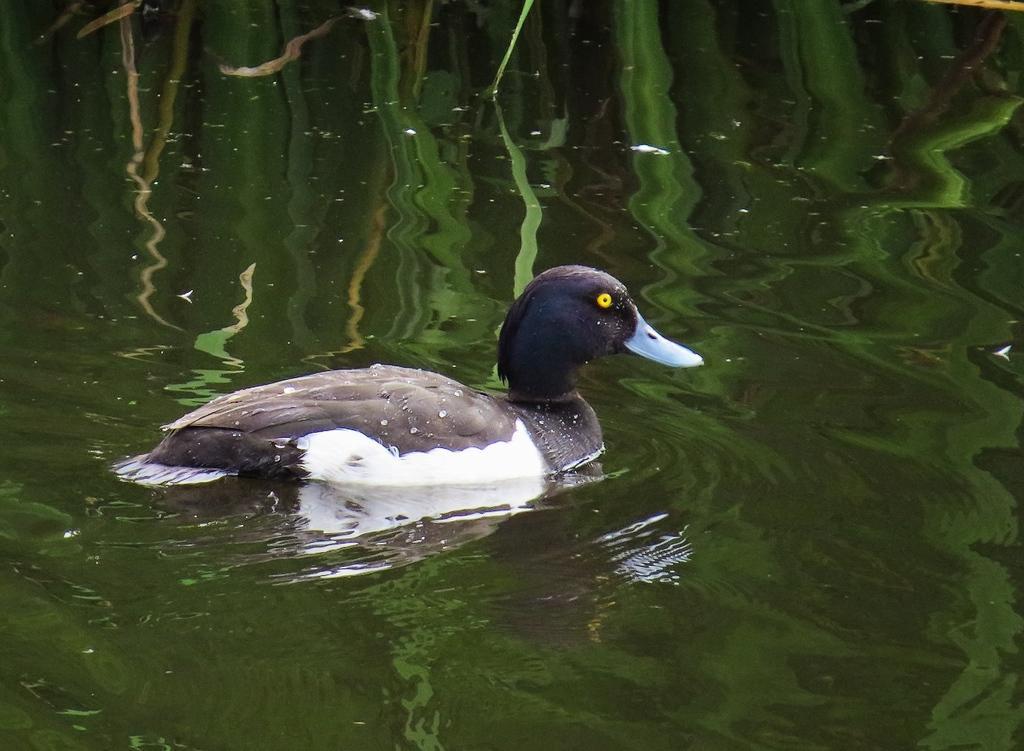How would you summarize this image in a sentence or two? In this image I can see water and on it I can see a black and white colour duck. 